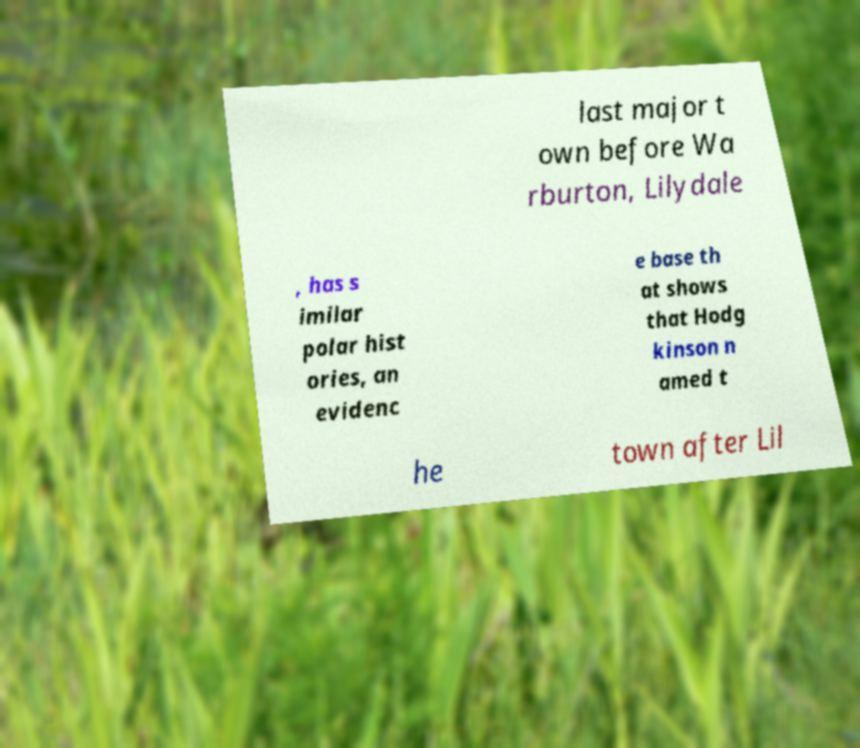Please read and relay the text visible in this image. What does it say? last major t own before Wa rburton, Lilydale , has s imilar polar hist ories, an evidenc e base th at shows that Hodg kinson n amed t he town after Lil 